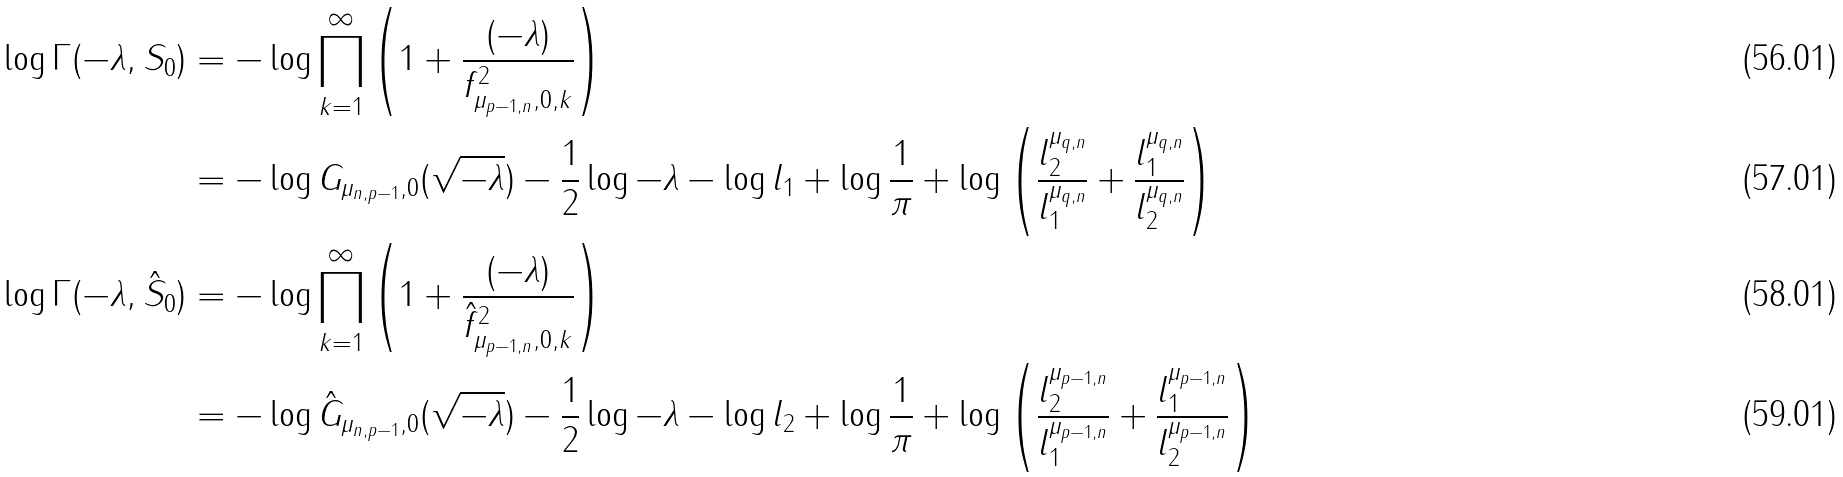Convert formula to latex. <formula><loc_0><loc_0><loc_500><loc_500>\log \Gamma ( - \lambda , S _ { 0 } ) & = - \log \prod _ { k = 1 } ^ { \infty } \left ( 1 + \frac { ( - \lambda ) } { f _ { \mu _ { p - 1 , n } , 0 , k } ^ { 2 } } \right ) \\ & = - \log G _ { \mu _ { n , p - 1 } , 0 } ( \sqrt { - \lambda } ) - \frac { 1 } { 2 } \log - \lambda - \log l _ { 1 } + \log \frac { 1 } { \pi } + \log \left ( \frac { l _ { 2 } ^ { \mu _ { q , n } } } { l _ { 1 } ^ { \mu _ { q , n } } } + \frac { l _ { 1 } ^ { \mu _ { q , n } } } { l _ { 2 } ^ { \mu _ { q , n } } } \right ) \\ \log \Gamma ( - \lambda , \hat { S } _ { 0 } ) & = - \log \prod _ { k = 1 } ^ { \infty } \left ( 1 + \frac { ( - \lambda ) } { \hat { f } _ { \mu _ { p - 1 , n } , 0 , k } ^ { 2 } } \right ) \\ & = - \log \hat { G } _ { \mu _ { n , p - 1 } , 0 } ( \sqrt { - \lambda } ) - \frac { 1 } { 2 } \log - \lambda - \log l _ { 2 } + \log \frac { 1 } { \pi } + \log \left ( \frac { l _ { 2 } ^ { \mu _ { p - 1 , n } } } { l _ { 1 } ^ { \mu _ { p - 1 , n } } } + \frac { l _ { 1 } ^ { \mu _ { p - 1 , n } } } { l _ { 2 } ^ { \mu _ { p - 1 , n } } } \right )</formula> 